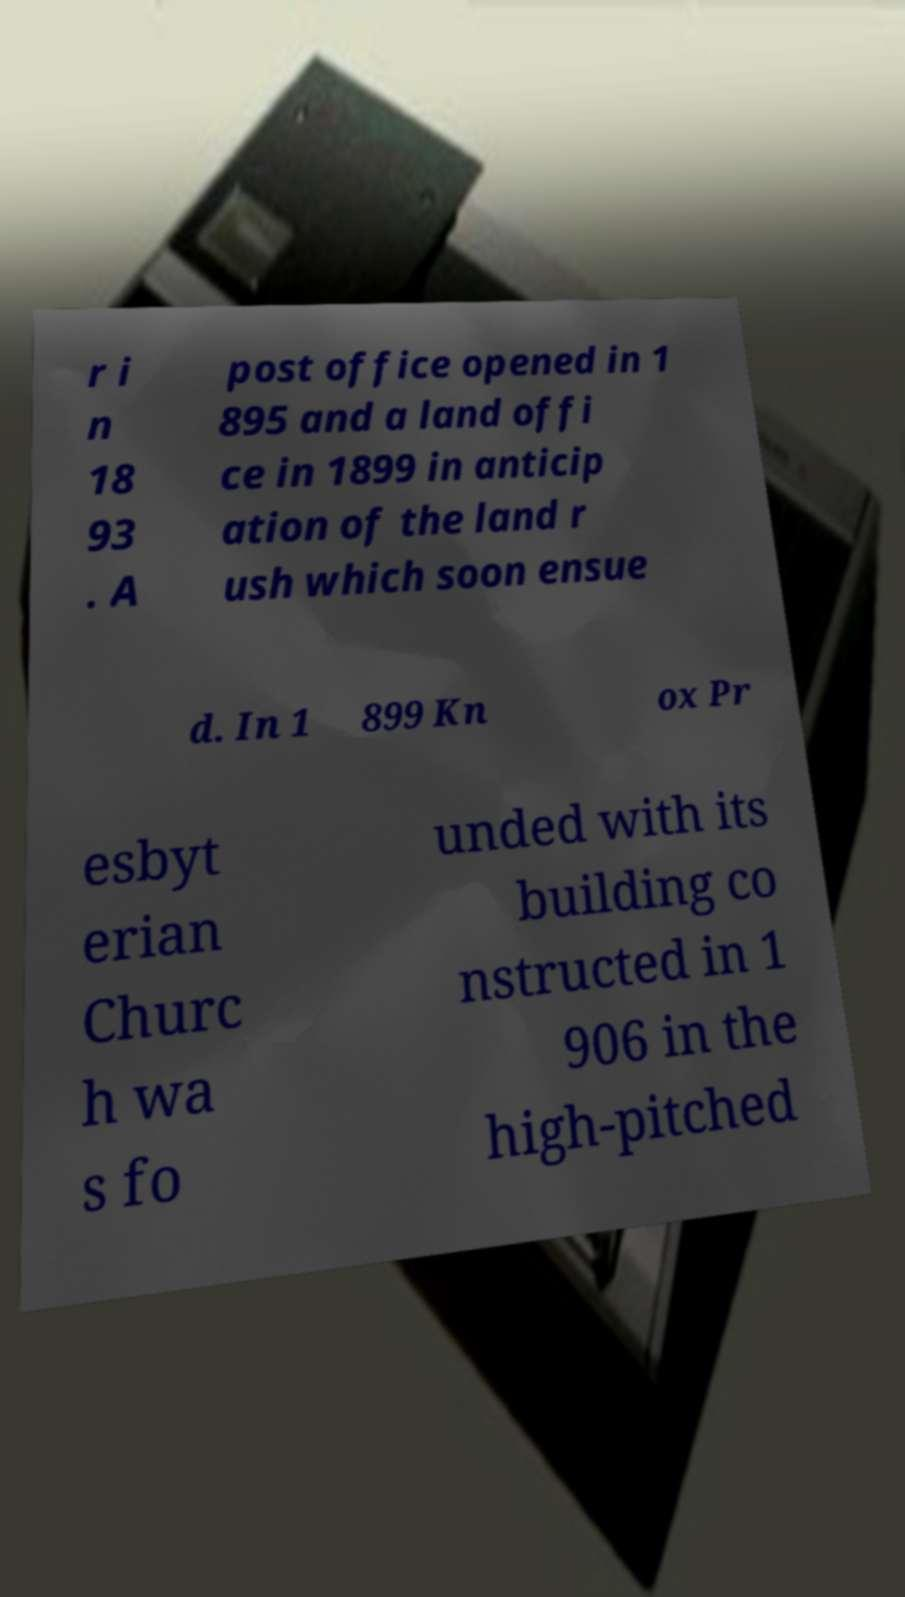Can you read and provide the text displayed in the image?This photo seems to have some interesting text. Can you extract and type it out for me? r i n 18 93 . A post office opened in 1 895 and a land offi ce in 1899 in anticip ation of the land r ush which soon ensue d. In 1 899 Kn ox Pr esbyt erian Churc h wa s fo unded with its building co nstructed in 1 906 in the high-pitched 